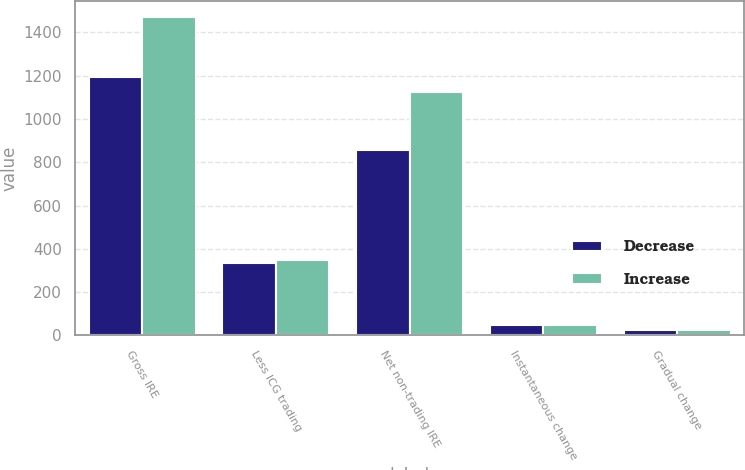Convert chart to OTSL. <chart><loc_0><loc_0><loc_500><loc_500><stacked_bar_chart><ecel><fcel>Gross IRE<fcel>Less ICG trading<fcel>Net non-trading IRE<fcel>Instantaneous change<fcel>Gradual change<nl><fcel>Decrease<fcel>1194<fcel>336<fcel>859<fcel>50<fcel>26<nl><fcel>Increase<fcel>1473<fcel>350<fcel>1123<fcel>50<fcel>26<nl></chart> 